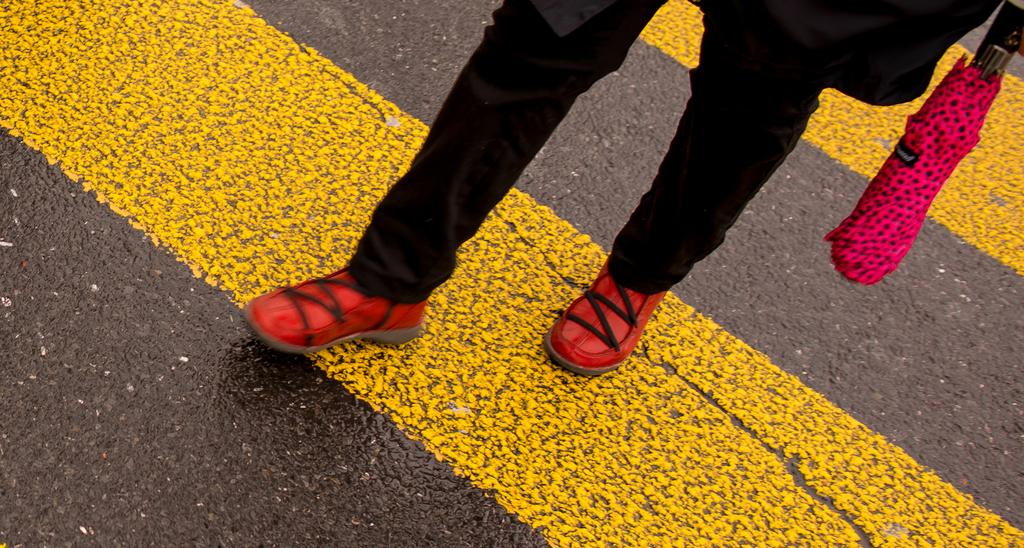What part of a person can be seen in the image? There are legs of a person visible in the image. Where are the legs located? The legs are on the road. What object is present on the right side of the image? There is an umbrella on the right side of the image. What type of lunch is being prepared in the image? There is no indication of lunch preparation in the image; it only shows legs on the road and an umbrella on the right side. 